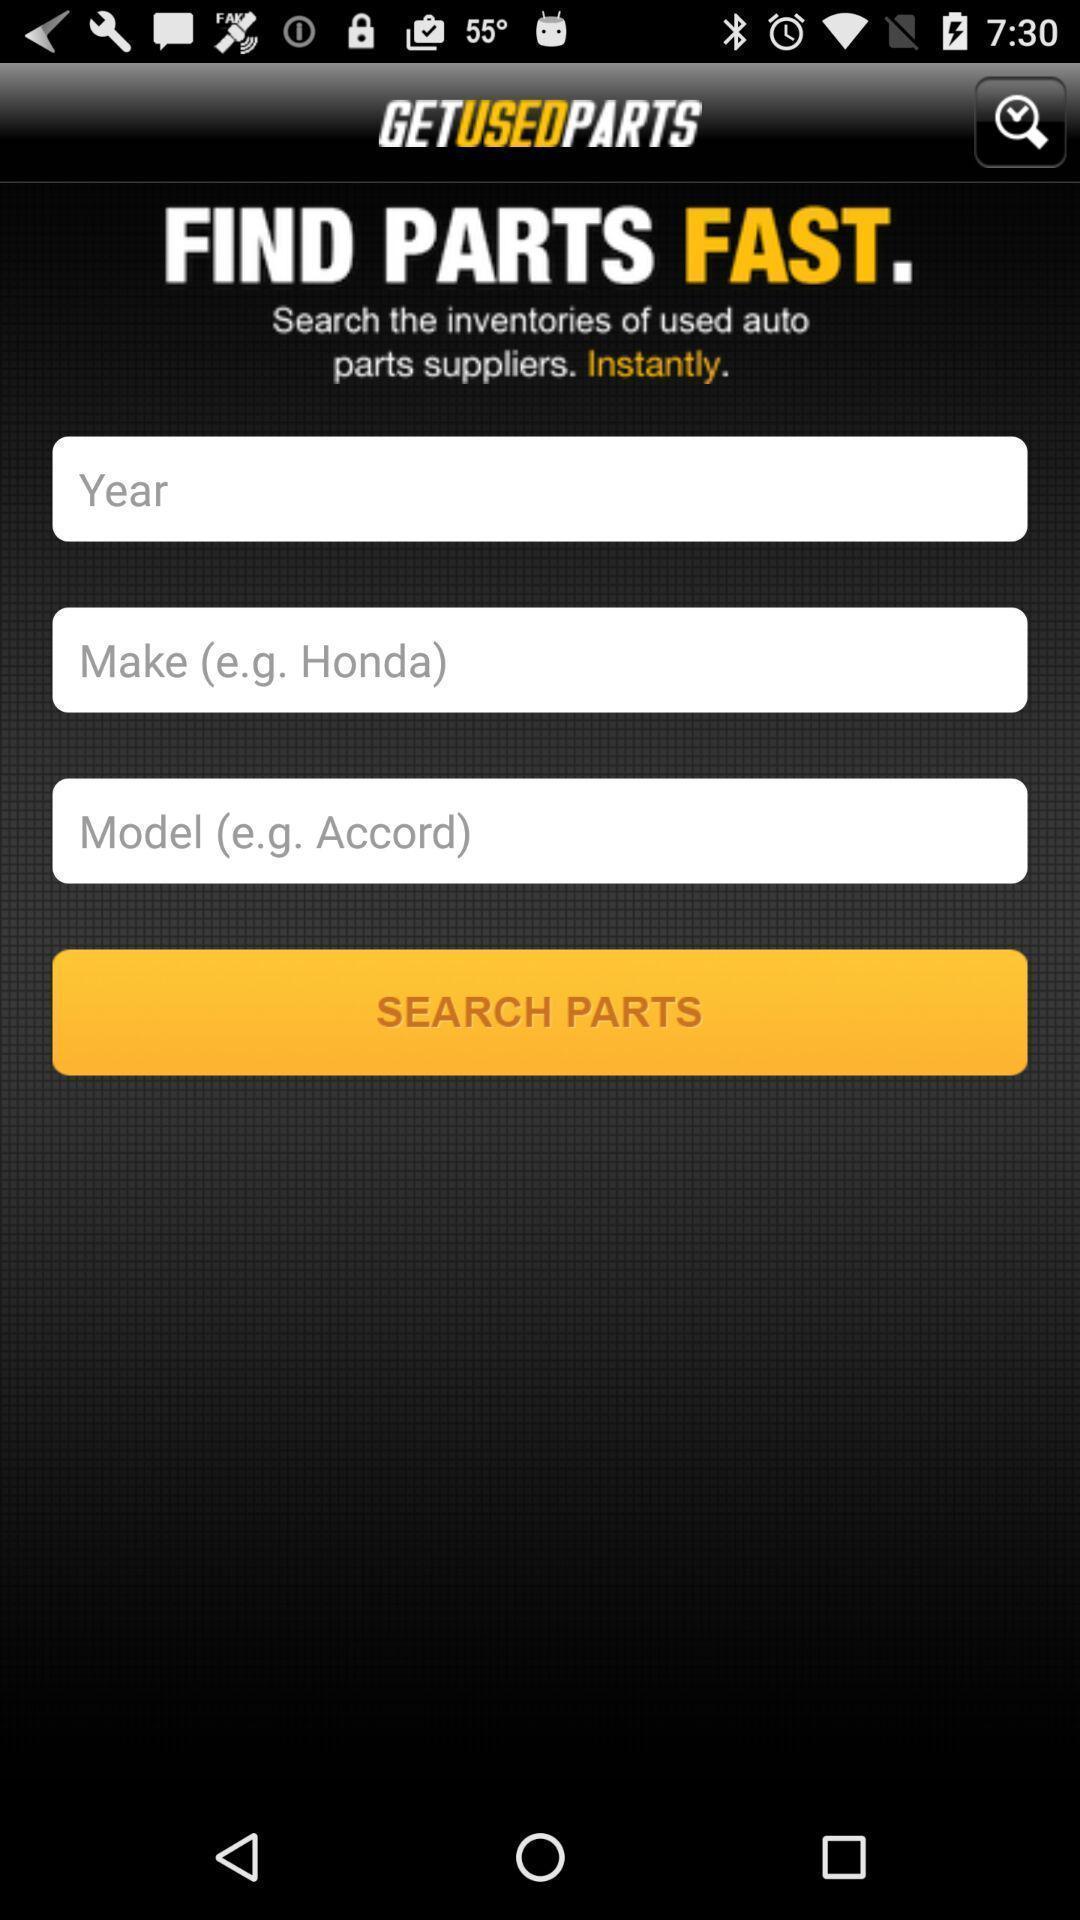Describe the visual elements of this screenshot. Search page to buy car parts online. 